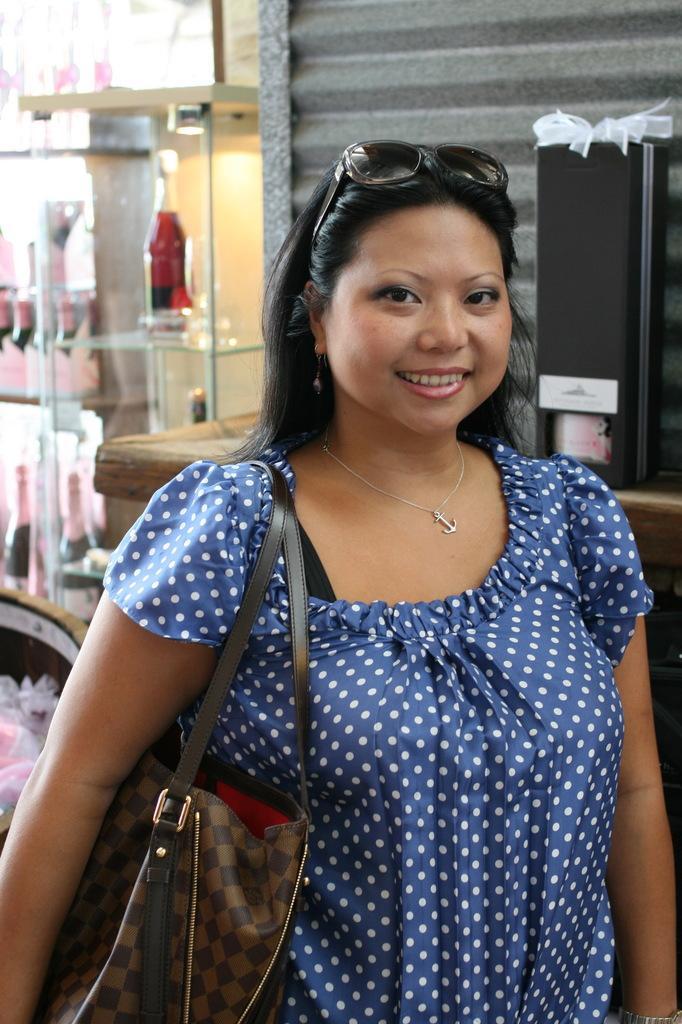Could you give a brief overview of what you see in this image? In this image there is a woman standing wearing big, glasses, in the background there is a glass shelf in that there is a bottle and a wall. 